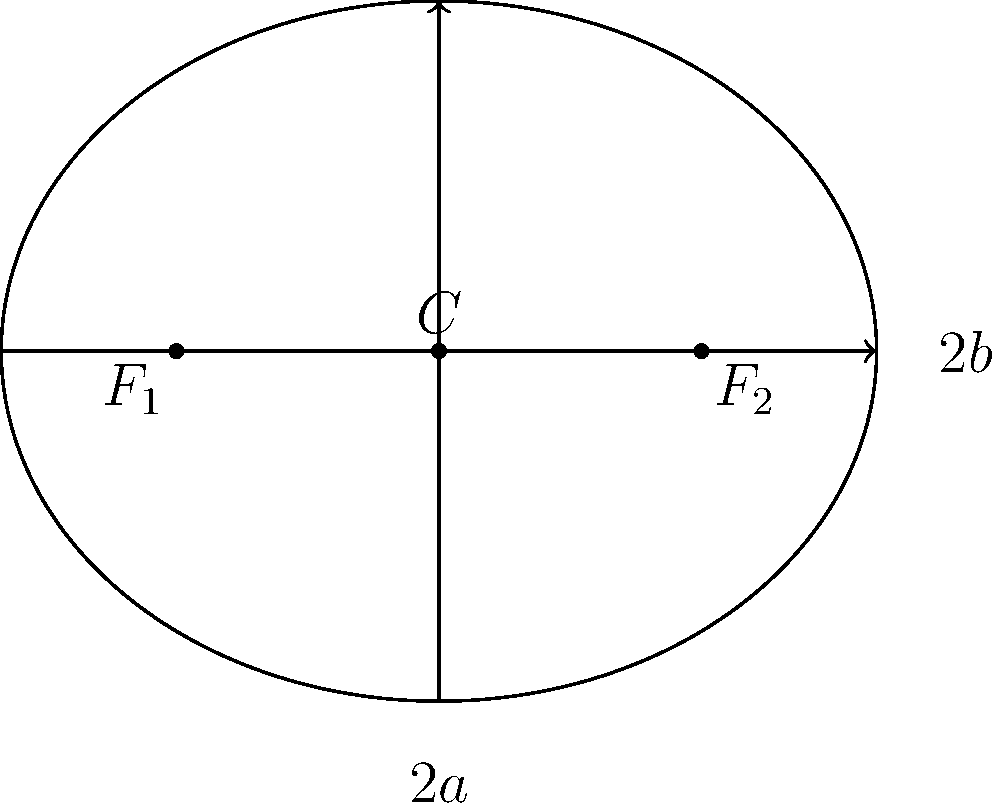In the ellipse shown above, the length of the major axis (2a) is 10 units, and the length of the minor axis (2b) is 8 units. Calculate the eccentricity of this ellipse. To find the eccentricity of an ellipse, we can follow these steps:

1) The eccentricity (e) of an ellipse is given by the formula:

   $$e = \sqrt{1 - \frac{b^2}{a^2}}$$

   where a is half the length of the major axis and b is half the length of the minor axis.

2) From the given information:
   - Major axis length (2a) = 10 units, so a = 5 units
   - Minor axis length (2b) = 8 units, so b = 4 units

3) Let's substitute these values into the formula:

   $$e = \sqrt{1 - \frac{4^2}{5^2}}$$

4) Simplify inside the parentheses:

   $$e = \sqrt{1 - \frac{16}{25}}$$

5) Perform the division:

   $$e = \sqrt{1 - 0.64}$$

6) Subtract:

   $$e = \sqrt{0.36}$$

7) Take the square root:

   $$e = 0.6$$

Thus, the eccentricity of the ellipse is 0.6.
Answer: 0.6 